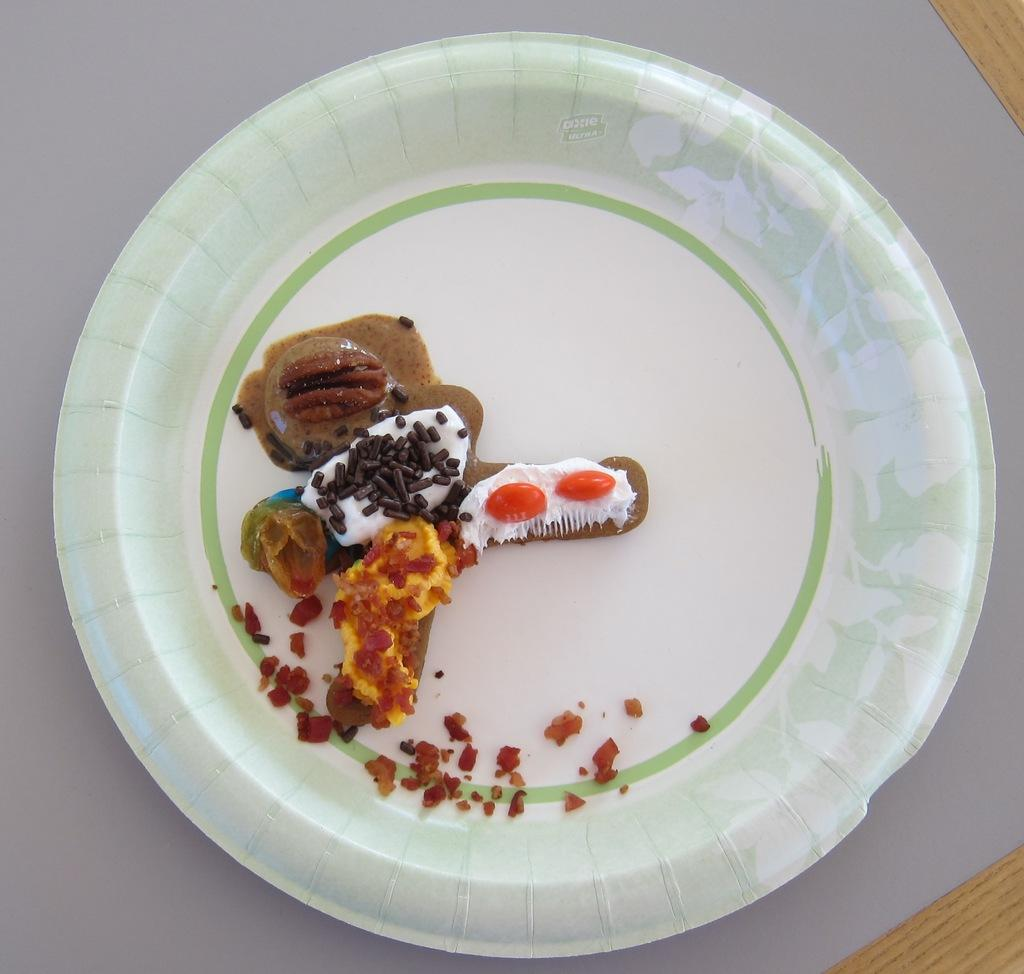What object is present on the table in the image? There is a plate in the image. Where is the plate located in the image? The plate is placed on a table. What is on the plate in the image? There is food in the plate. What is the value of the tooth in the image? There is no tooth present in the image, so it is not possible to determine its value. 